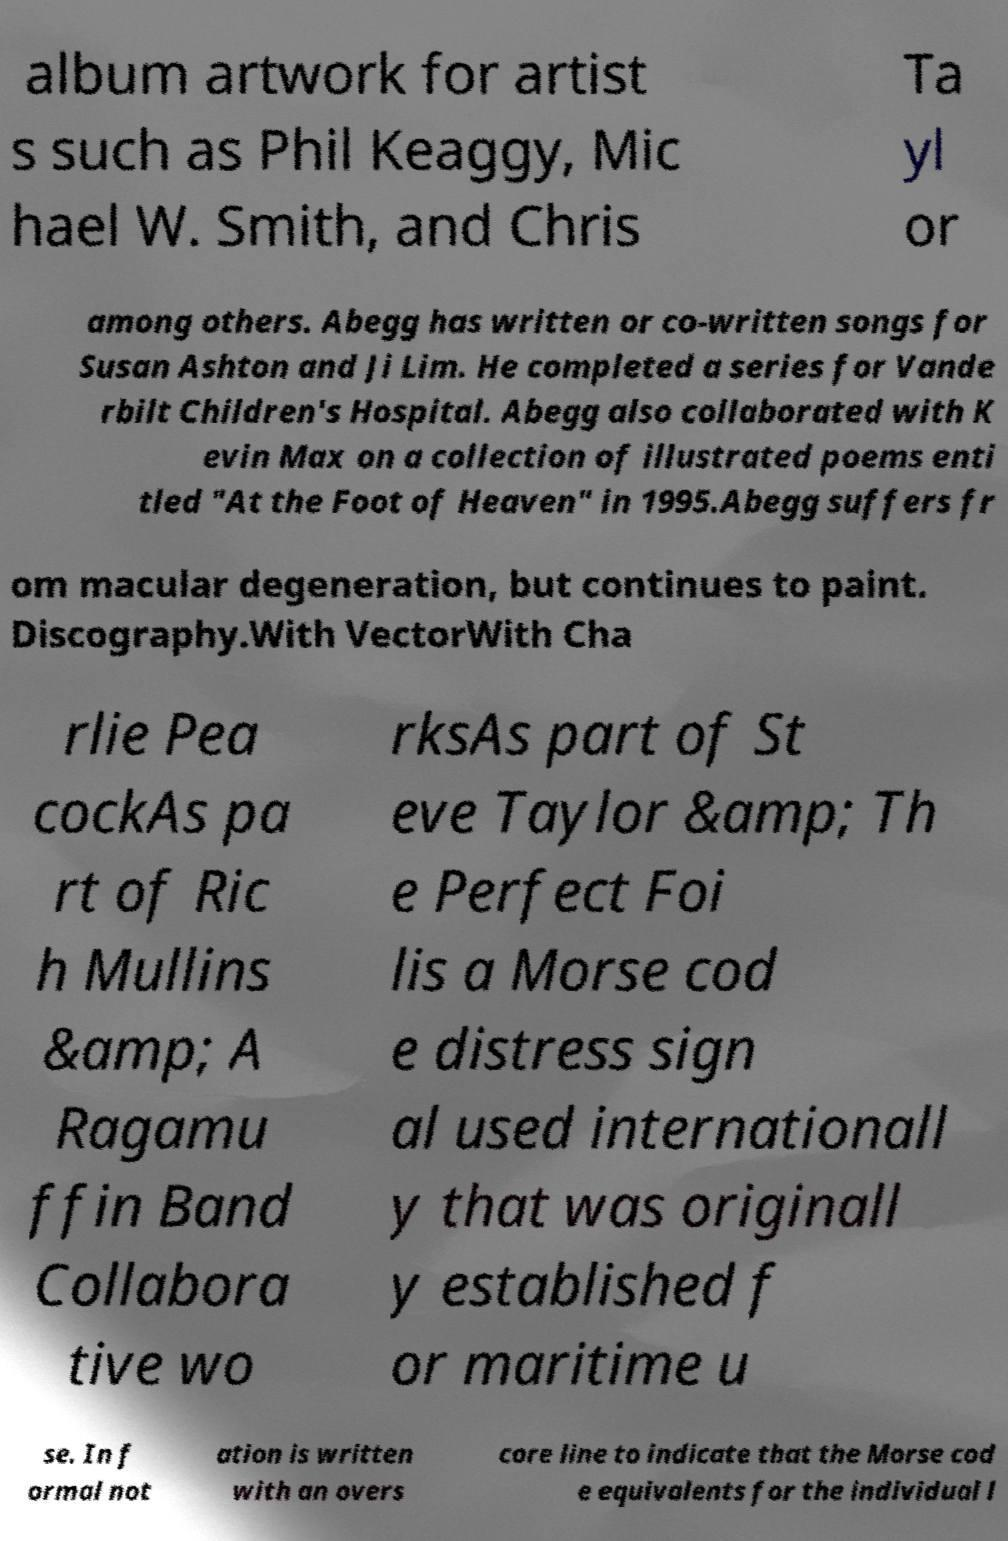There's text embedded in this image that I need extracted. Can you transcribe it verbatim? album artwork for artist s such as Phil Keaggy, Mic hael W. Smith, and Chris Ta yl or among others. Abegg has written or co-written songs for Susan Ashton and Ji Lim. He completed a series for Vande rbilt Children's Hospital. Abegg also collaborated with K evin Max on a collection of illustrated poems enti tled "At the Foot of Heaven" in 1995.Abegg suffers fr om macular degeneration, but continues to paint. Discography.With VectorWith Cha rlie Pea cockAs pa rt of Ric h Mullins &amp; A Ragamu ffin Band Collabora tive wo rksAs part of St eve Taylor &amp; Th e Perfect Foi lis a Morse cod e distress sign al used internationall y that was originall y established f or maritime u se. In f ormal not ation is written with an overs core line to indicate that the Morse cod e equivalents for the individual l 